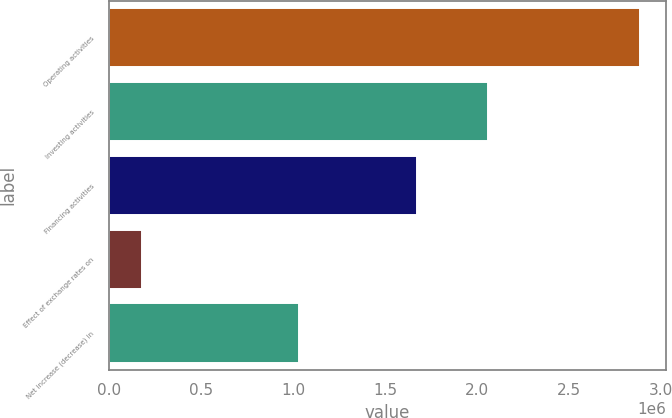Convert chart. <chart><loc_0><loc_0><loc_500><loc_500><bar_chart><fcel>Operating activities<fcel>Investing activities<fcel>Financing activities<fcel>Effect of exchange rates on<fcel>Net increase (decrease) in<nl><fcel>2.882e+06<fcel>2.05735e+06<fcel>1.67385e+06<fcel>183061<fcel>1.03226e+06<nl></chart> 